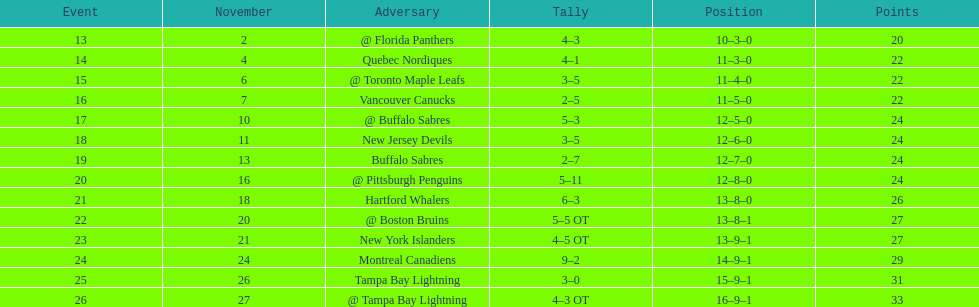Who had the most assists on the 1993-1994 flyers? Mark Recchi. 